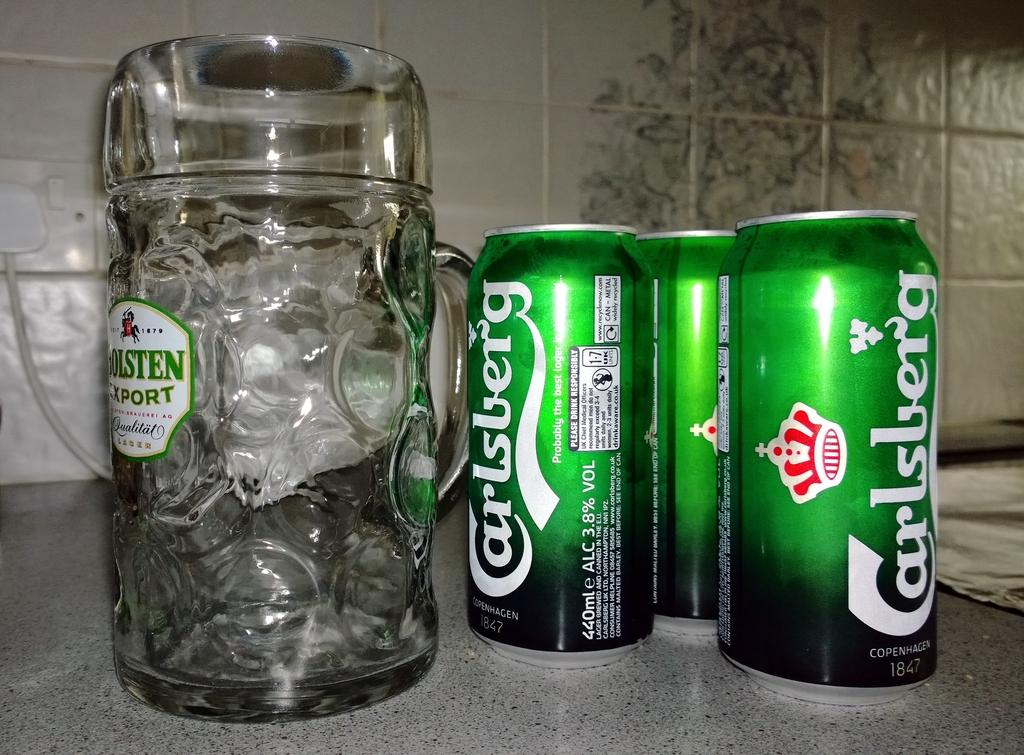<image>
Offer a succinct explanation of the picture presented. A row of three beer cans that say Carlsberg next to an empty mug. 